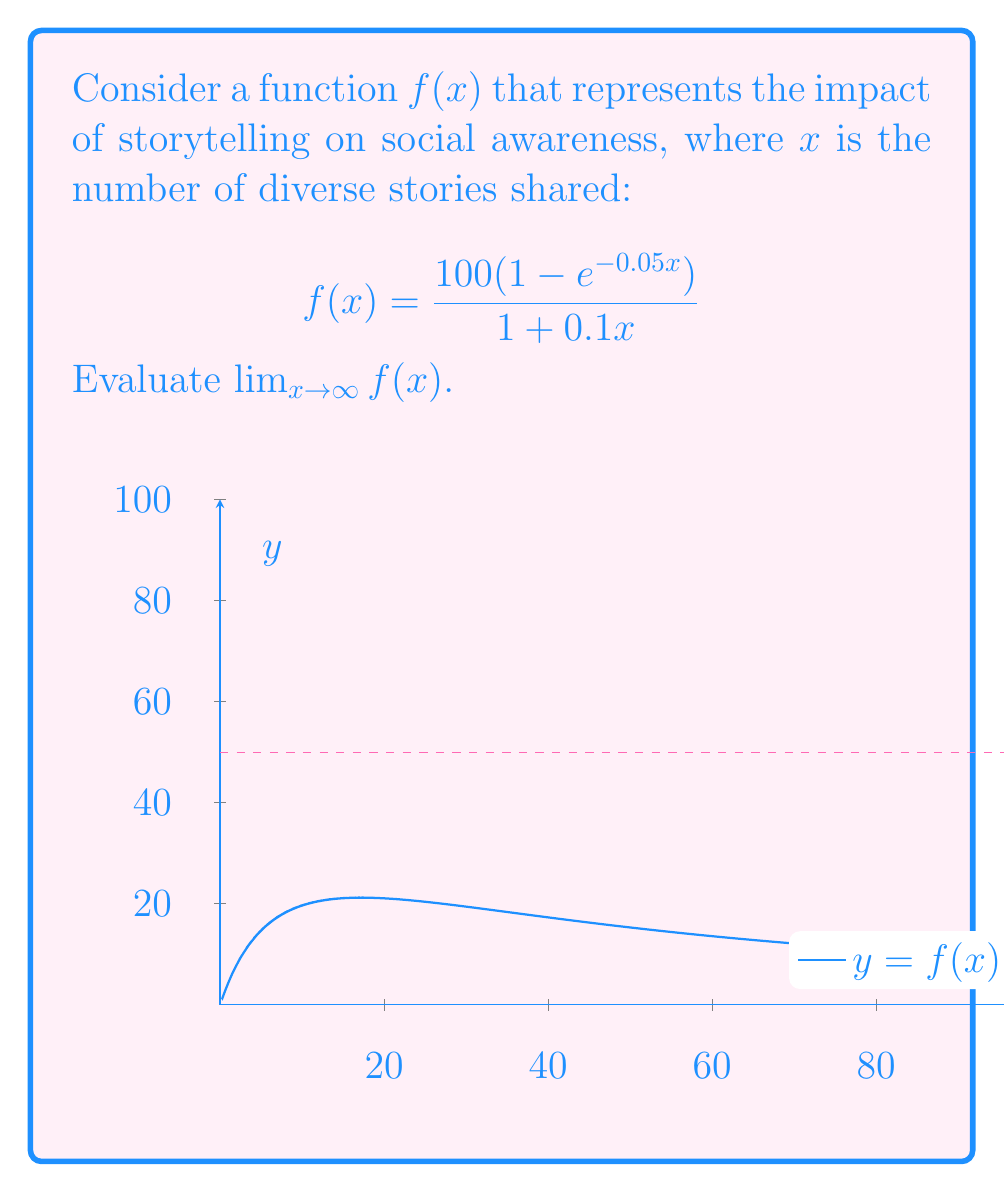Can you answer this question? To evaluate this limit, we'll use L'Hôpital's rule:

1) First, let's rewrite the function:
   $$f(x) = \frac{100 - 100e^{-0.05x}}{1 + 0.1x}$$

2) As $x \to \infty$, both numerator and denominator approach $\infty$, so we have an indeterminate form $\frac{\infty}{\infty}$.

3) Apply L'Hôpital's rule by differentiating numerator and denominator separately:

   $$\lim_{x \to \infty} f(x) = \lim_{x \to \infty} \frac{\frac{d}{dx}(100 - 100e^{-0.05x})}{\frac{d}{dx}(1 + 0.1x)}$$

4) Evaluate the derivatives:
   $$= \lim_{x \to \infty} \frac{5e^{-0.05x}}{0.1}$$

5) Simplify:
   $$= \lim_{x \to \infty} 50e^{-0.05x}$$

6) As $x \to \infty$, $e^{-0.05x} \to 0$, so:
   $$\lim_{x \to \infty} 50e^{-0.05x} = 50 \cdot 0 = 0$$

Therefore, the limit of the impact function as the number of diverse stories approaches infinity is 0.
Answer: $0$ 